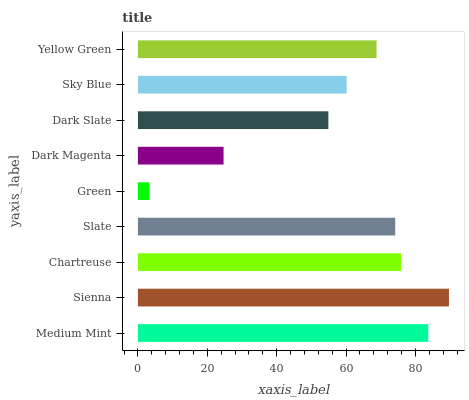Is Green the minimum?
Answer yes or no. Yes. Is Sienna the maximum?
Answer yes or no. Yes. Is Chartreuse the minimum?
Answer yes or no. No. Is Chartreuse the maximum?
Answer yes or no. No. Is Sienna greater than Chartreuse?
Answer yes or no. Yes. Is Chartreuse less than Sienna?
Answer yes or no. Yes. Is Chartreuse greater than Sienna?
Answer yes or no. No. Is Sienna less than Chartreuse?
Answer yes or no. No. Is Yellow Green the high median?
Answer yes or no. Yes. Is Yellow Green the low median?
Answer yes or no. Yes. Is Dark Slate the high median?
Answer yes or no. No. Is Slate the low median?
Answer yes or no. No. 